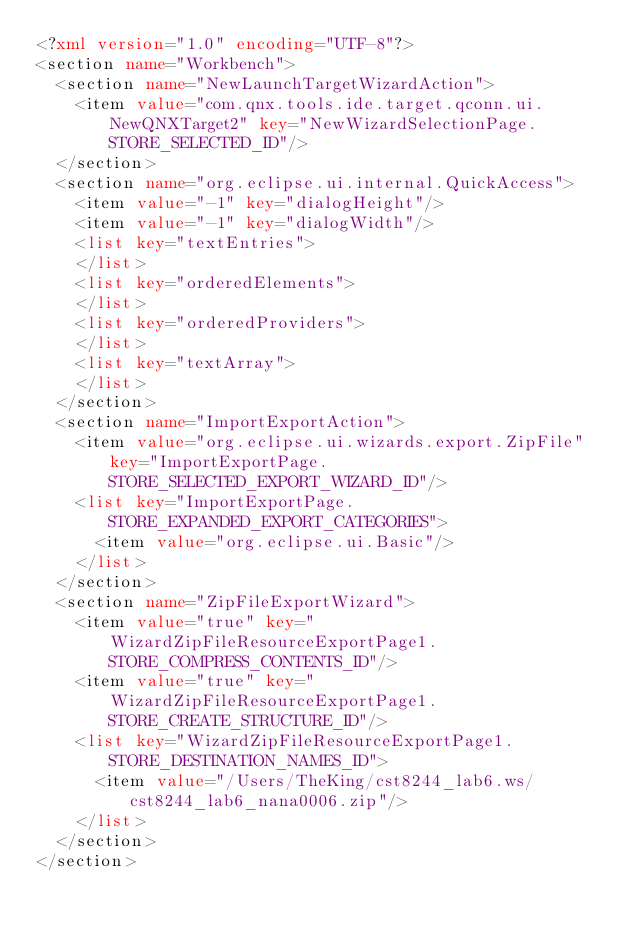Convert code to text. <code><loc_0><loc_0><loc_500><loc_500><_XML_><?xml version="1.0" encoding="UTF-8"?>
<section name="Workbench">
	<section name="NewLaunchTargetWizardAction">
		<item value="com.qnx.tools.ide.target.qconn.ui.NewQNXTarget2" key="NewWizardSelectionPage.STORE_SELECTED_ID"/>
	</section>
	<section name="org.eclipse.ui.internal.QuickAccess">
		<item value="-1" key="dialogHeight"/>
		<item value="-1" key="dialogWidth"/>
		<list key="textEntries">
		</list>
		<list key="orderedElements">
		</list>
		<list key="orderedProviders">
		</list>
		<list key="textArray">
		</list>
	</section>
	<section name="ImportExportAction">
		<item value="org.eclipse.ui.wizards.export.ZipFile" key="ImportExportPage.STORE_SELECTED_EXPORT_WIZARD_ID"/>
		<list key="ImportExportPage.STORE_EXPANDED_EXPORT_CATEGORIES">
			<item value="org.eclipse.ui.Basic"/>
		</list>
	</section>
	<section name="ZipFileExportWizard">
		<item value="true" key="WizardZipFileResourceExportPage1.STORE_COMPRESS_CONTENTS_ID"/>
		<item value="true" key="WizardZipFileResourceExportPage1.STORE_CREATE_STRUCTURE_ID"/>
		<list key="WizardZipFileResourceExportPage1.STORE_DESTINATION_NAMES_ID">
			<item value="/Users/TheKing/cst8244_lab6.ws/cst8244_lab6_nana0006.zip"/>
		</list>
	</section>
</section>
</code> 